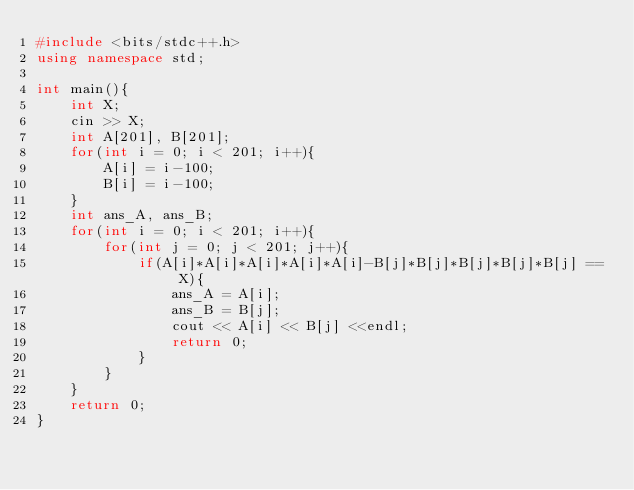<code> <loc_0><loc_0><loc_500><loc_500><_C++_>#include <bits/stdc++.h>
using namespace std;

int main(){
    int X;
    cin >> X;
    int A[201], B[201];
    for(int i = 0; i < 201; i++){
        A[i] = i-100;
        B[i] = i-100;
    }
    int ans_A, ans_B;
    for(int i = 0; i < 201; i++){
        for(int j = 0; j < 201; j++){
            if(A[i]*A[i]*A[i]*A[i]*A[i]-B[j]*B[j]*B[j]*B[j]*B[j] == X){
                ans_A = A[i];
                ans_B = B[j];
                cout << A[i] << B[j] <<endl;
                return 0;
            }
        }
    }
    return 0;
}</code> 